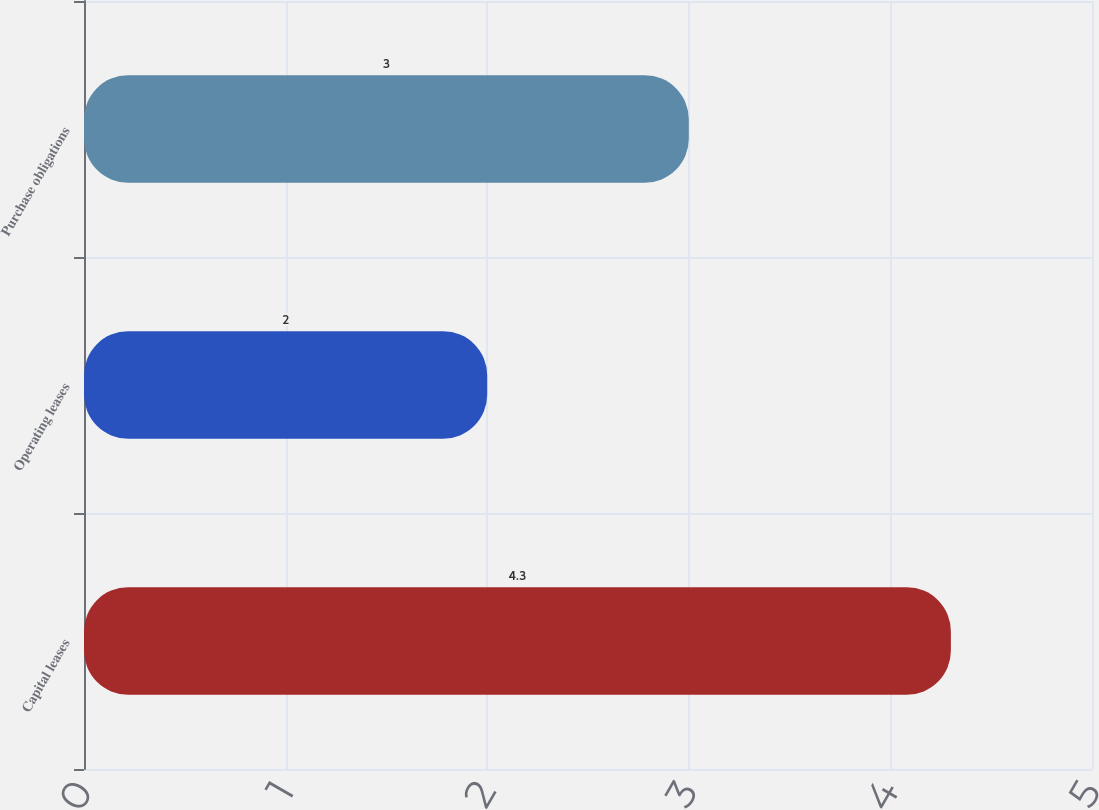Convert chart. <chart><loc_0><loc_0><loc_500><loc_500><bar_chart><fcel>Capital leases<fcel>Operating leases<fcel>Purchase obligations<nl><fcel>4.3<fcel>2<fcel>3<nl></chart> 